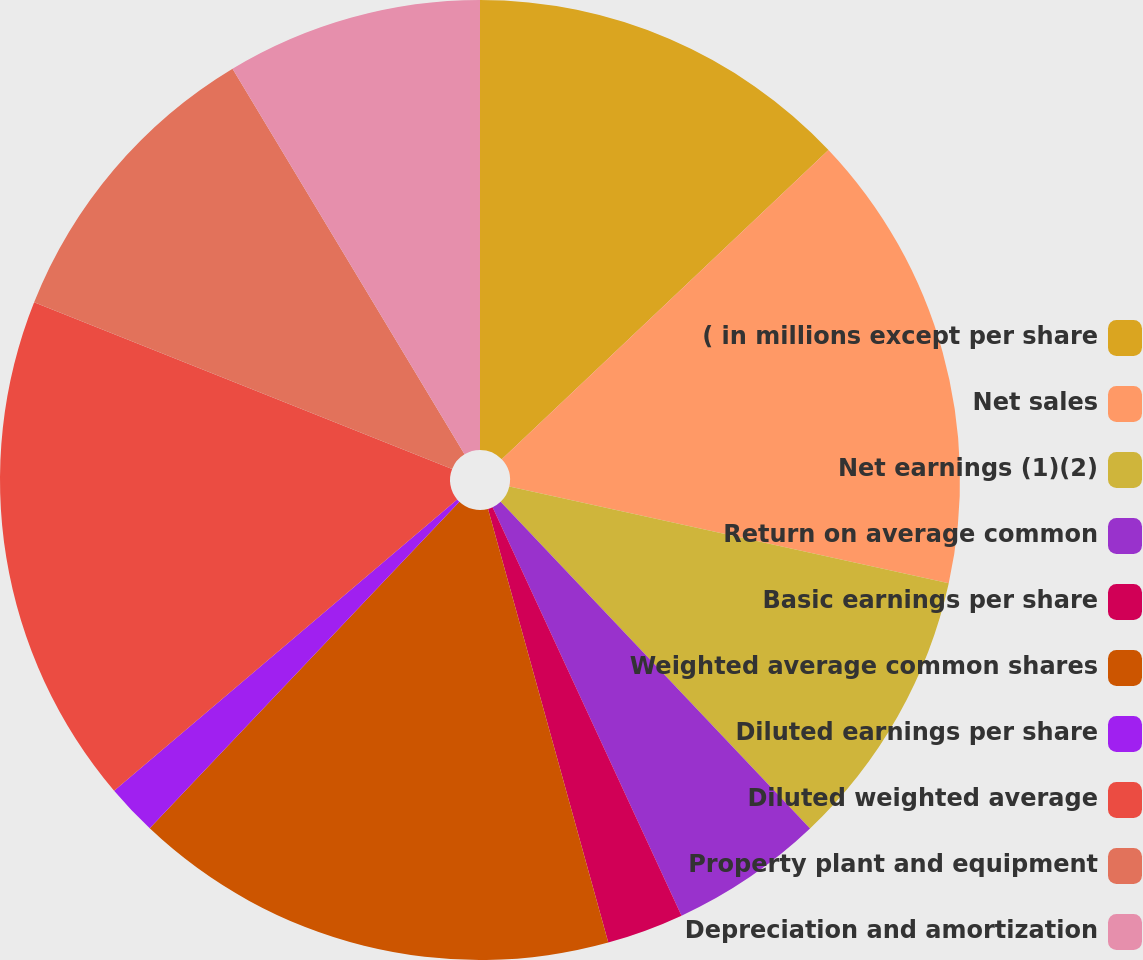<chart> <loc_0><loc_0><loc_500><loc_500><pie_chart><fcel>( in millions except per share<fcel>Net sales<fcel>Net earnings (1)(2)<fcel>Return on average common<fcel>Basic earnings per share<fcel>Weighted average common shares<fcel>Diluted earnings per share<fcel>Diluted weighted average<fcel>Property plant and equipment<fcel>Depreciation and amortization<nl><fcel>12.93%<fcel>15.52%<fcel>9.48%<fcel>5.17%<fcel>2.59%<fcel>16.38%<fcel>1.72%<fcel>17.24%<fcel>10.34%<fcel>8.62%<nl></chart> 